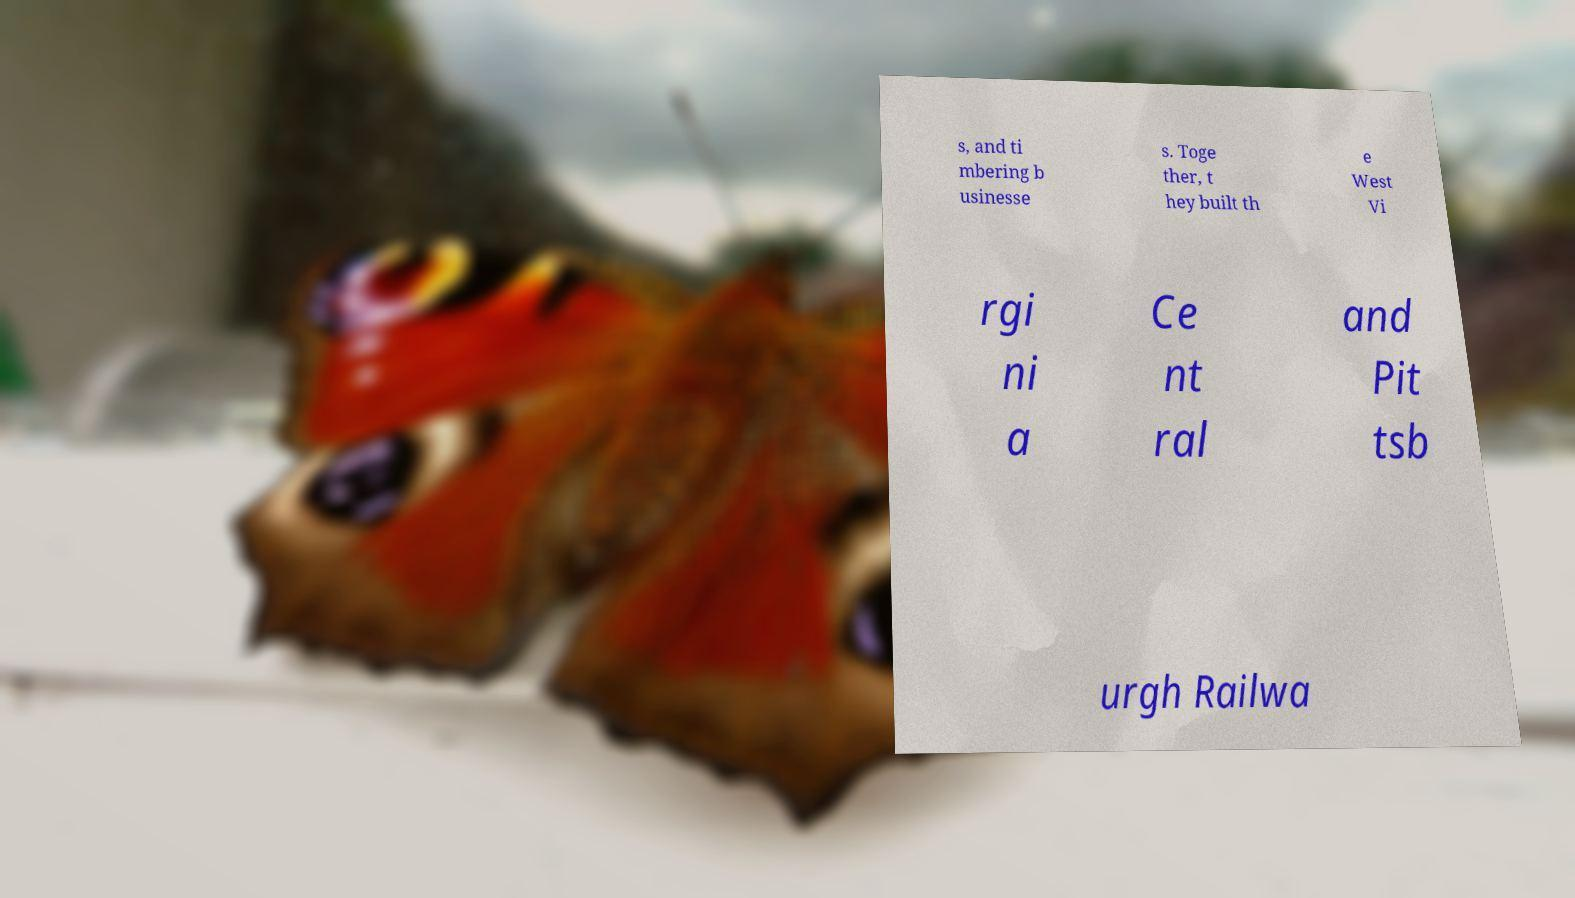Please read and relay the text visible in this image. What does it say? s, and ti mbering b usinesse s. Toge ther, t hey built th e West Vi rgi ni a Ce nt ral and Pit tsb urgh Railwa 